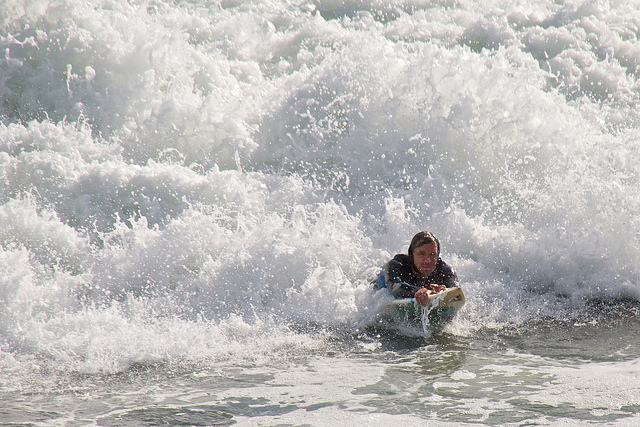What does the surfer’s pose suggest about their level of experience? The surfer's pose, with a low center of gravity and arms extended for balance, suggests they are adept at handling the surf and are likely experienced. What makes you think the surfer is experienced? Experience can often be inferred from a surfer’s composure on the board, the smoothness with which they ride the wave, and their ability to maintain balance in the dynamic environment of the ocean. 